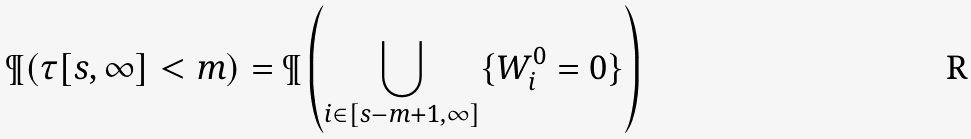Convert formula to latex. <formula><loc_0><loc_0><loc_500><loc_500>\P ( \tau [ s , \infty ] < m ) = \P \left ( \bigcup _ { i \in [ s - m + 1 , \infty ] } \{ W ^ { 0 } _ { i } = 0 \} \right )</formula> 